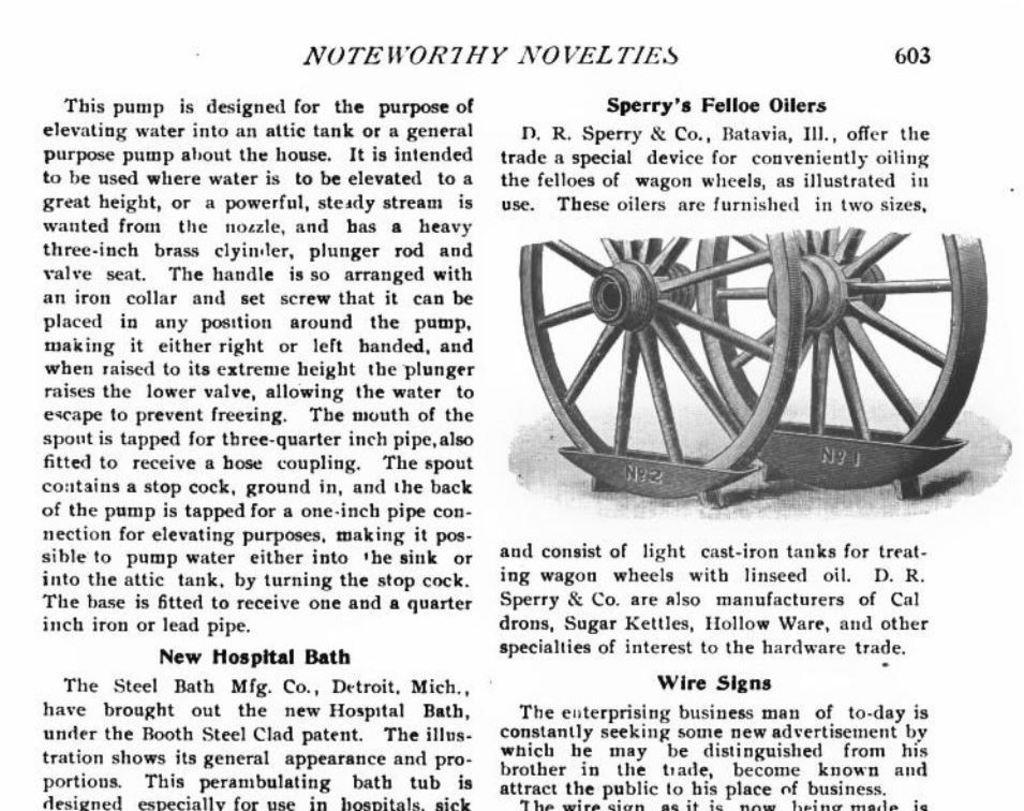What type of content is displayed in the image? The image is a newspaper page. What is the main title on the page? The title on the page is "NOTEWORTHY NOVELTIES". Is there any text below the title? Yes, there is text below the title. What can be seen in the images on the page? There are two wheels images on the page. What type of iron is used to press the newspaper in the image? There is no iron present in the image, as it is a newspaper page and not a physical newspaper. 